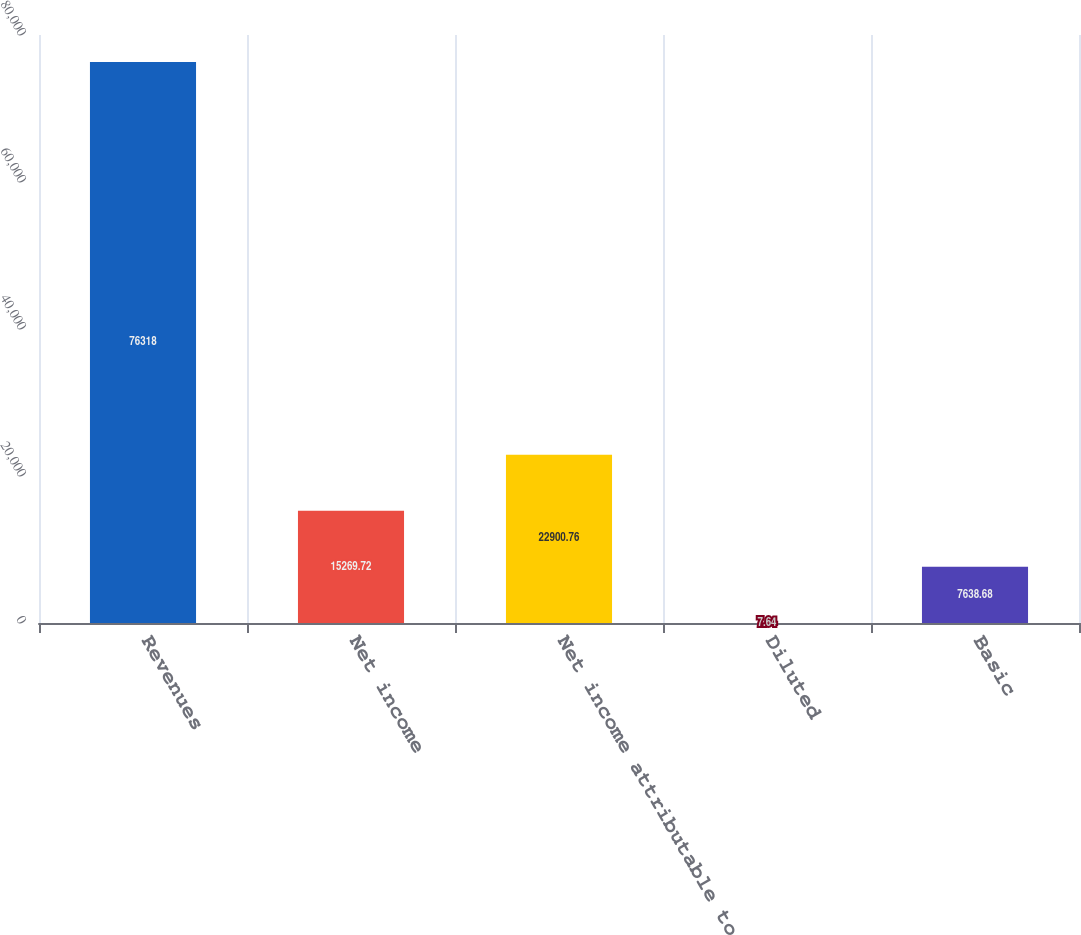Convert chart to OTSL. <chart><loc_0><loc_0><loc_500><loc_500><bar_chart><fcel>Revenues<fcel>Net income<fcel>Net income attributable to<fcel>Diluted<fcel>Basic<nl><fcel>76318<fcel>15269.7<fcel>22900.8<fcel>7.64<fcel>7638.68<nl></chart> 